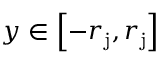<formula> <loc_0><loc_0><loc_500><loc_500>y \in \left [ - r _ { j } , r _ { j } \right ]</formula> 